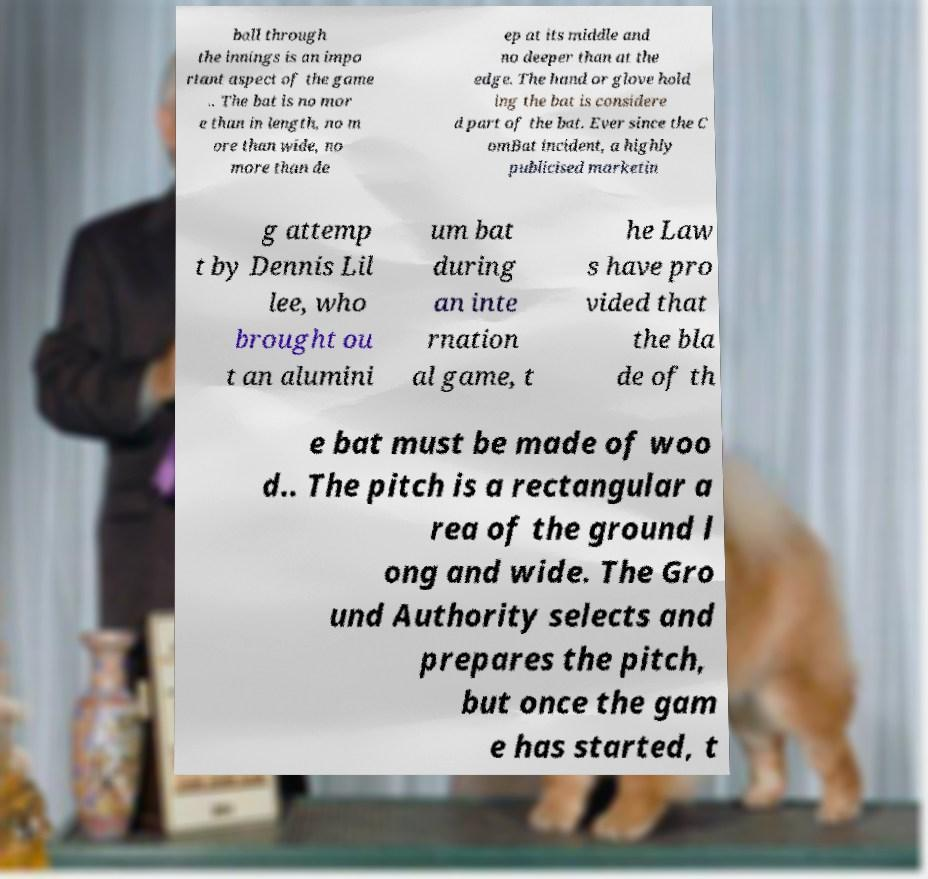Could you extract and type out the text from this image? ball through the innings is an impo rtant aspect of the game .. The bat is no mor e than in length, no m ore than wide, no more than de ep at its middle and no deeper than at the edge. The hand or glove hold ing the bat is considere d part of the bat. Ever since the C omBat incident, a highly publicised marketin g attemp t by Dennis Lil lee, who brought ou t an alumini um bat during an inte rnation al game, t he Law s have pro vided that the bla de of th e bat must be made of woo d.. The pitch is a rectangular a rea of the ground l ong and wide. The Gro und Authority selects and prepares the pitch, but once the gam e has started, t 